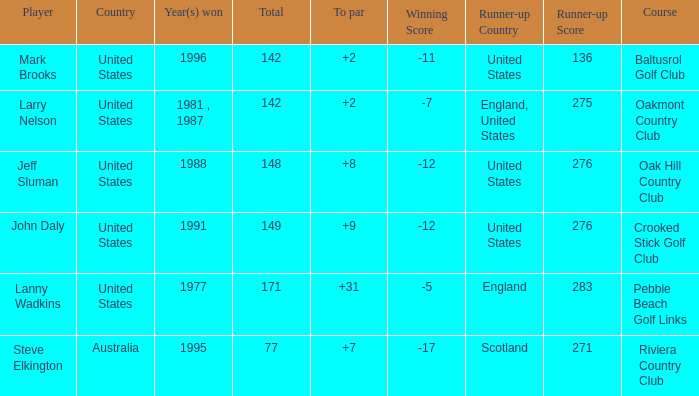Name the Total of jeff sluman? 148.0. 